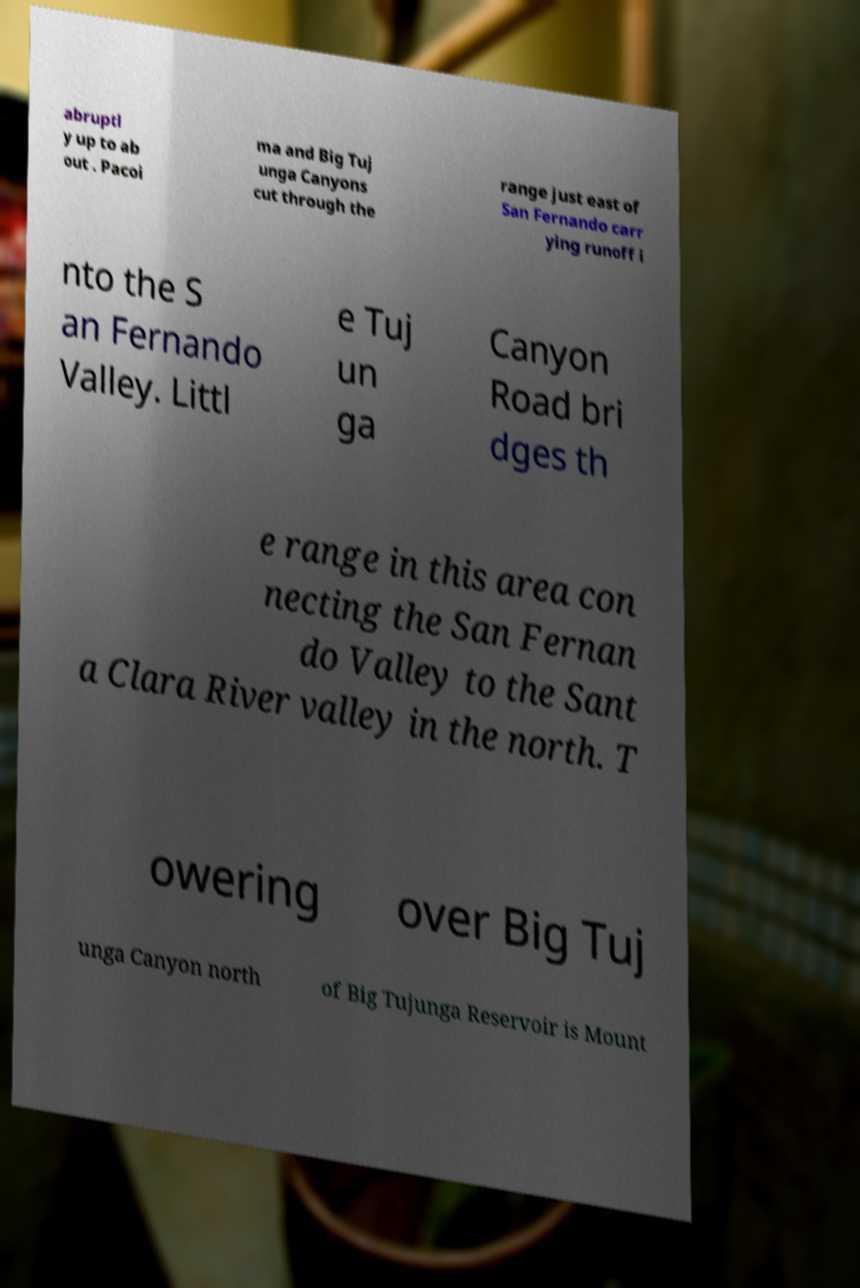For documentation purposes, I need the text within this image transcribed. Could you provide that? abruptl y up to ab out . Pacoi ma and Big Tuj unga Canyons cut through the range just east of San Fernando carr ying runoff i nto the S an Fernando Valley. Littl e Tuj un ga Canyon Road bri dges th e range in this area con necting the San Fernan do Valley to the Sant a Clara River valley in the north. T owering over Big Tuj unga Canyon north of Big Tujunga Reservoir is Mount 